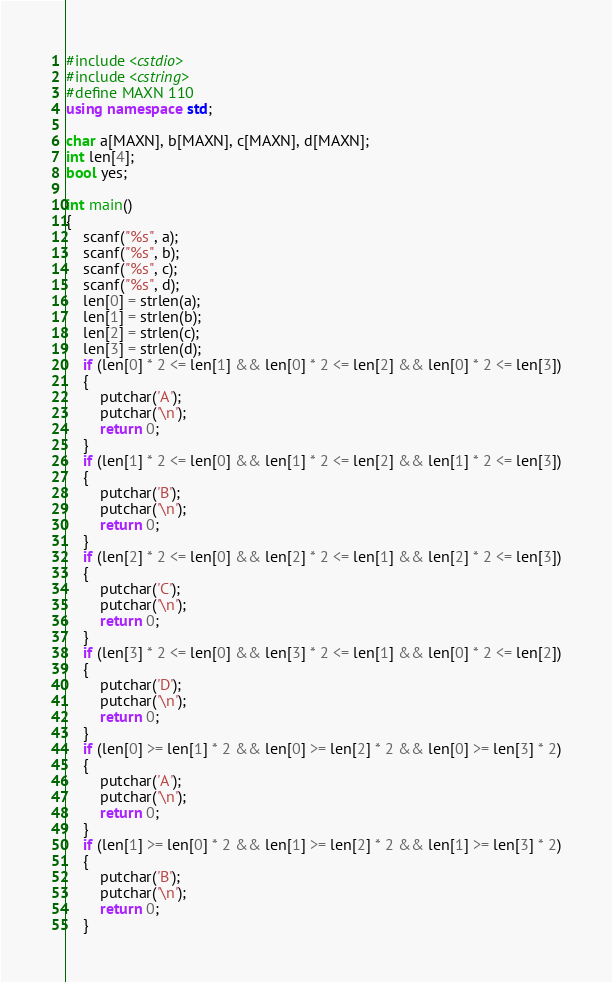Convert code to text. <code><loc_0><loc_0><loc_500><loc_500><_C++_>#include <cstdio>
#include <cstring>
#define MAXN 110
using namespace std;

char a[MAXN], b[MAXN], c[MAXN], d[MAXN];
int len[4];
bool yes;

int main()
{
	scanf("%s", a);
	scanf("%s", b);
	scanf("%s", c);
	scanf("%s", d);
	len[0] = strlen(a);
	len[1] = strlen(b);
	len[2] = strlen(c);
	len[3] = strlen(d);
	if (len[0] * 2 <= len[1] && len[0] * 2 <= len[2] && len[0] * 2 <= len[3])
	{
		putchar('A');
		putchar('\n');
		return 0;
	}
	if (len[1] * 2 <= len[0] && len[1] * 2 <= len[2] && len[1] * 2 <= len[3])
	{
		putchar('B');
		putchar('\n');
		return 0;
	}
	if (len[2] * 2 <= len[0] && len[2] * 2 <= len[1] && len[2] * 2 <= len[3])
	{
		putchar('C');
		putchar('\n');
		return 0;
	}
	if (len[3] * 2 <= len[0] && len[3] * 2 <= len[1] && len[0] * 2 <= len[2])
	{
		putchar('D');
		putchar('\n');
		return 0;
	}
	if (len[0] >= len[1] * 2 && len[0] >= len[2] * 2 && len[0] >= len[3] * 2)
	{
		putchar('A');
		putchar('\n');
		return 0;
	}
	if (len[1] >= len[0] * 2 && len[1] >= len[2] * 2 && len[1] >= len[3] * 2)
	{
		putchar('B');
		putchar('\n');
		return 0;
	}</code> 